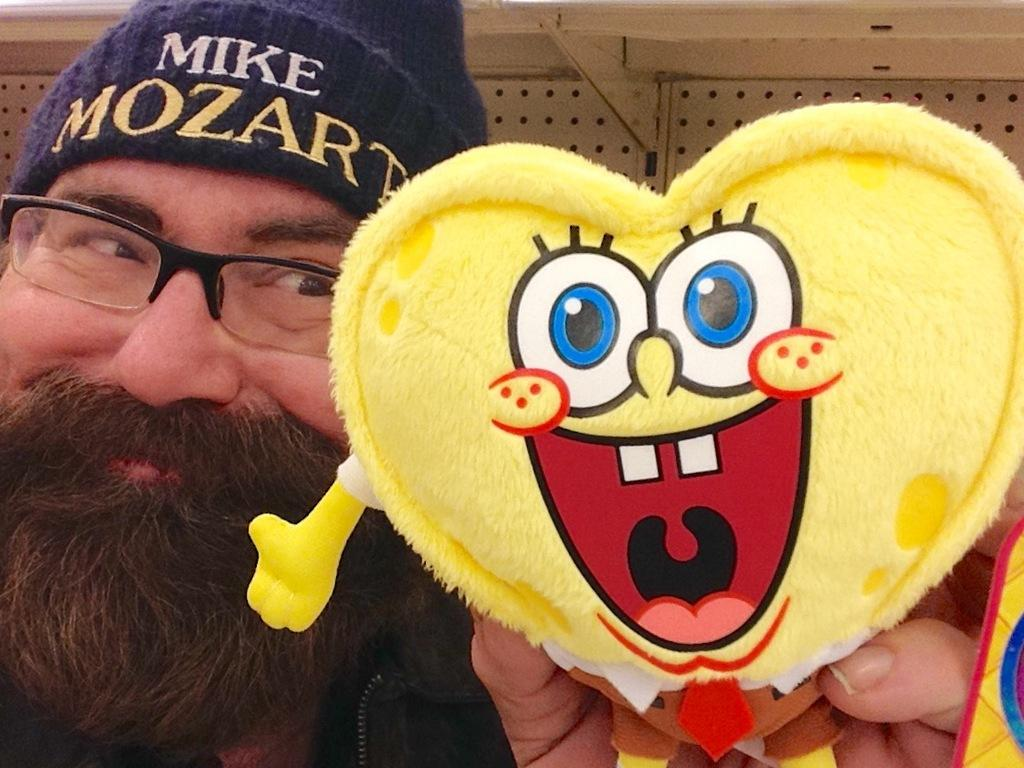Who is present in the image? There is a man in the image. What is the man wearing on his head? The man is wearing a cap. What accessory is the man wearing on his face? The man is wearing glasses. What object is the man holding in his hand? The man is holding a soft toy in his hand. What is the caption written on the man's finger in the image? There is no caption written on the man's finger in the image. 